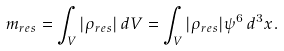Convert formula to latex. <formula><loc_0><loc_0><loc_500><loc_500>m _ { r e s } = \int _ { V } | \rho _ { r e s } | \, d V = \int _ { V } | \rho _ { r e s } | \psi ^ { 6 } \, d ^ { 3 } x .</formula> 